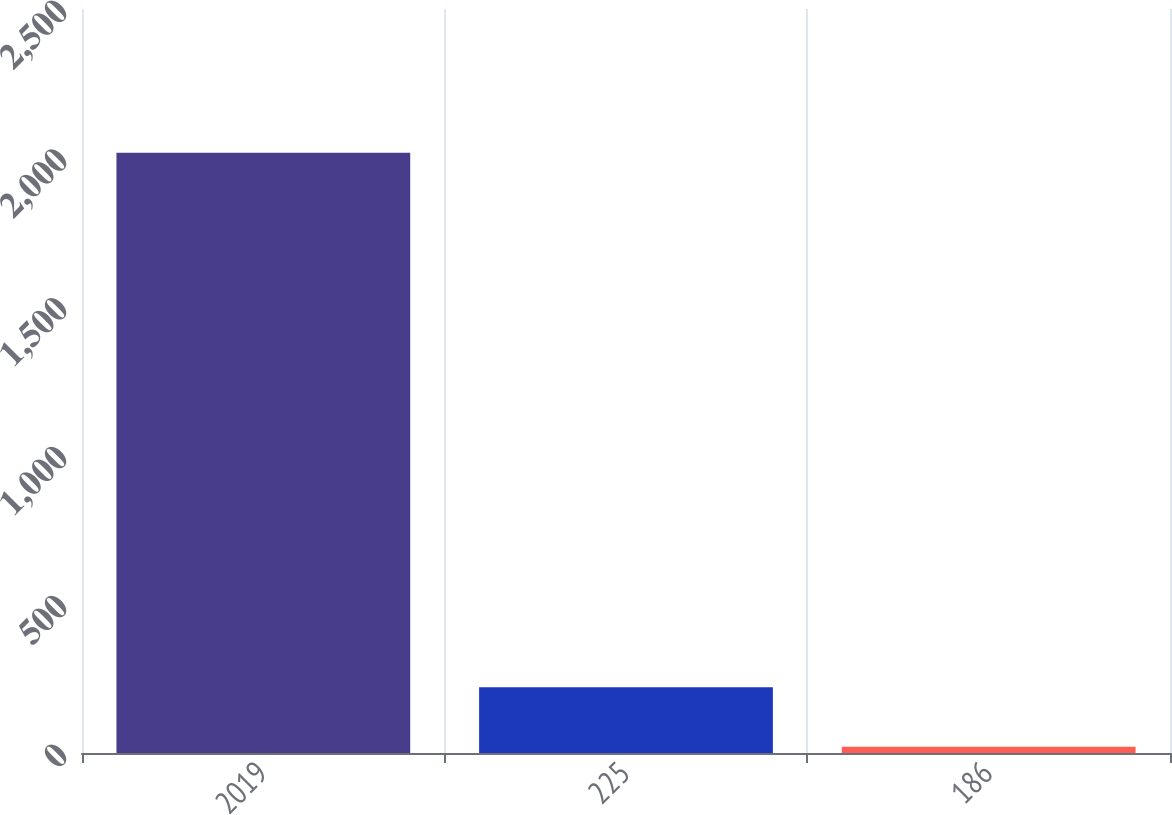<chart> <loc_0><loc_0><loc_500><loc_500><bar_chart><fcel>2019<fcel>225<fcel>186<nl><fcel>2017<fcel>220.6<fcel>21<nl></chart> 